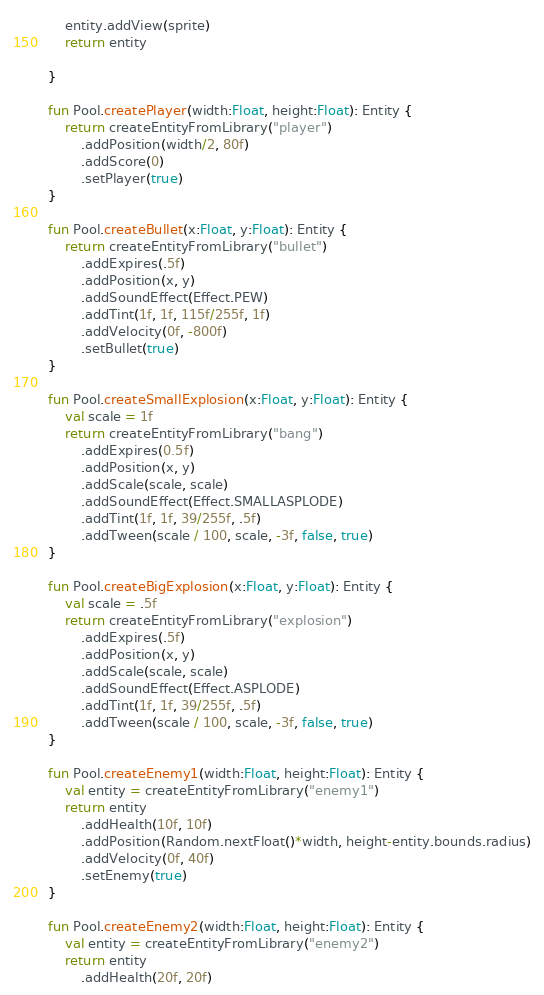Convert code to text. <code><loc_0><loc_0><loc_500><loc_500><_Kotlin_>    entity.addView(sprite)
    return entity

}

fun Pool.createPlayer(width:Float, height:Float): Entity {
    return createEntityFromLibrary("player")
        .addPosition(width/2, 80f)
        .addScore(0)
        .setPlayer(true)
}

fun Pool.createBullet(x:Float, y:Float): Entity {
    return createEntityFromLibrary("bullet")
        .addExpires(.5f)
        .addPosition(x, y)
        .addSoundEffect(Effect.PEW)
        .addTint(1f, 1f, 115f/255f, 1f)
        .addVelocity(0f, -800f)
        .setBullet(true)
}

fun Pool.createSmallExplosion(x:Float, y:Float): Entity {
    val scale = 1f
    return createEntityFromLibrary("bang")
        .addExpires(0.5f)
        .addPosition(x, y)
        .addScale(scale, scale)
        .addSoundEffect(Effect.SMALLASPLODE)
        .addTint(1f, 1f, 39/255f, .5f)
        .addTween(scale / 100, scale, -3f, false, true)
}

fun Pool.createBigExplosion(x:Float, y:Float): Entity {
    val scale = .5f
    return createEntityFromLibrary("explosion")
        .addExpires(.5f)
        .addPosition(x, y)
        .addScale(scale, scale)
        .addSoundEffect(Effect.ASPLODE)
        .addTint(1f, 1f, 39/255f, .5f)
        .addTween(scale / 100, scale, -3f, false, true)
}

fun Pool.createEnemy1(width:Float, height:Float): Entity {
    val entity = createEntityFromLibrary("enemy1")
    return entity
        .addHealth(10f, 10f)
        .addPosition(Random.nextFloat()*width, height-entity.bounds.radius)
        .addVelocity(0f, 40f)
        .setEnemy(true)
}

fun Pool.createEnemy2(width:Float, height:Float): Entity {
    val entity = createEntityFromLibrary("enemy2")
    return entity
        .addHealth(20f, 20f)</code> 